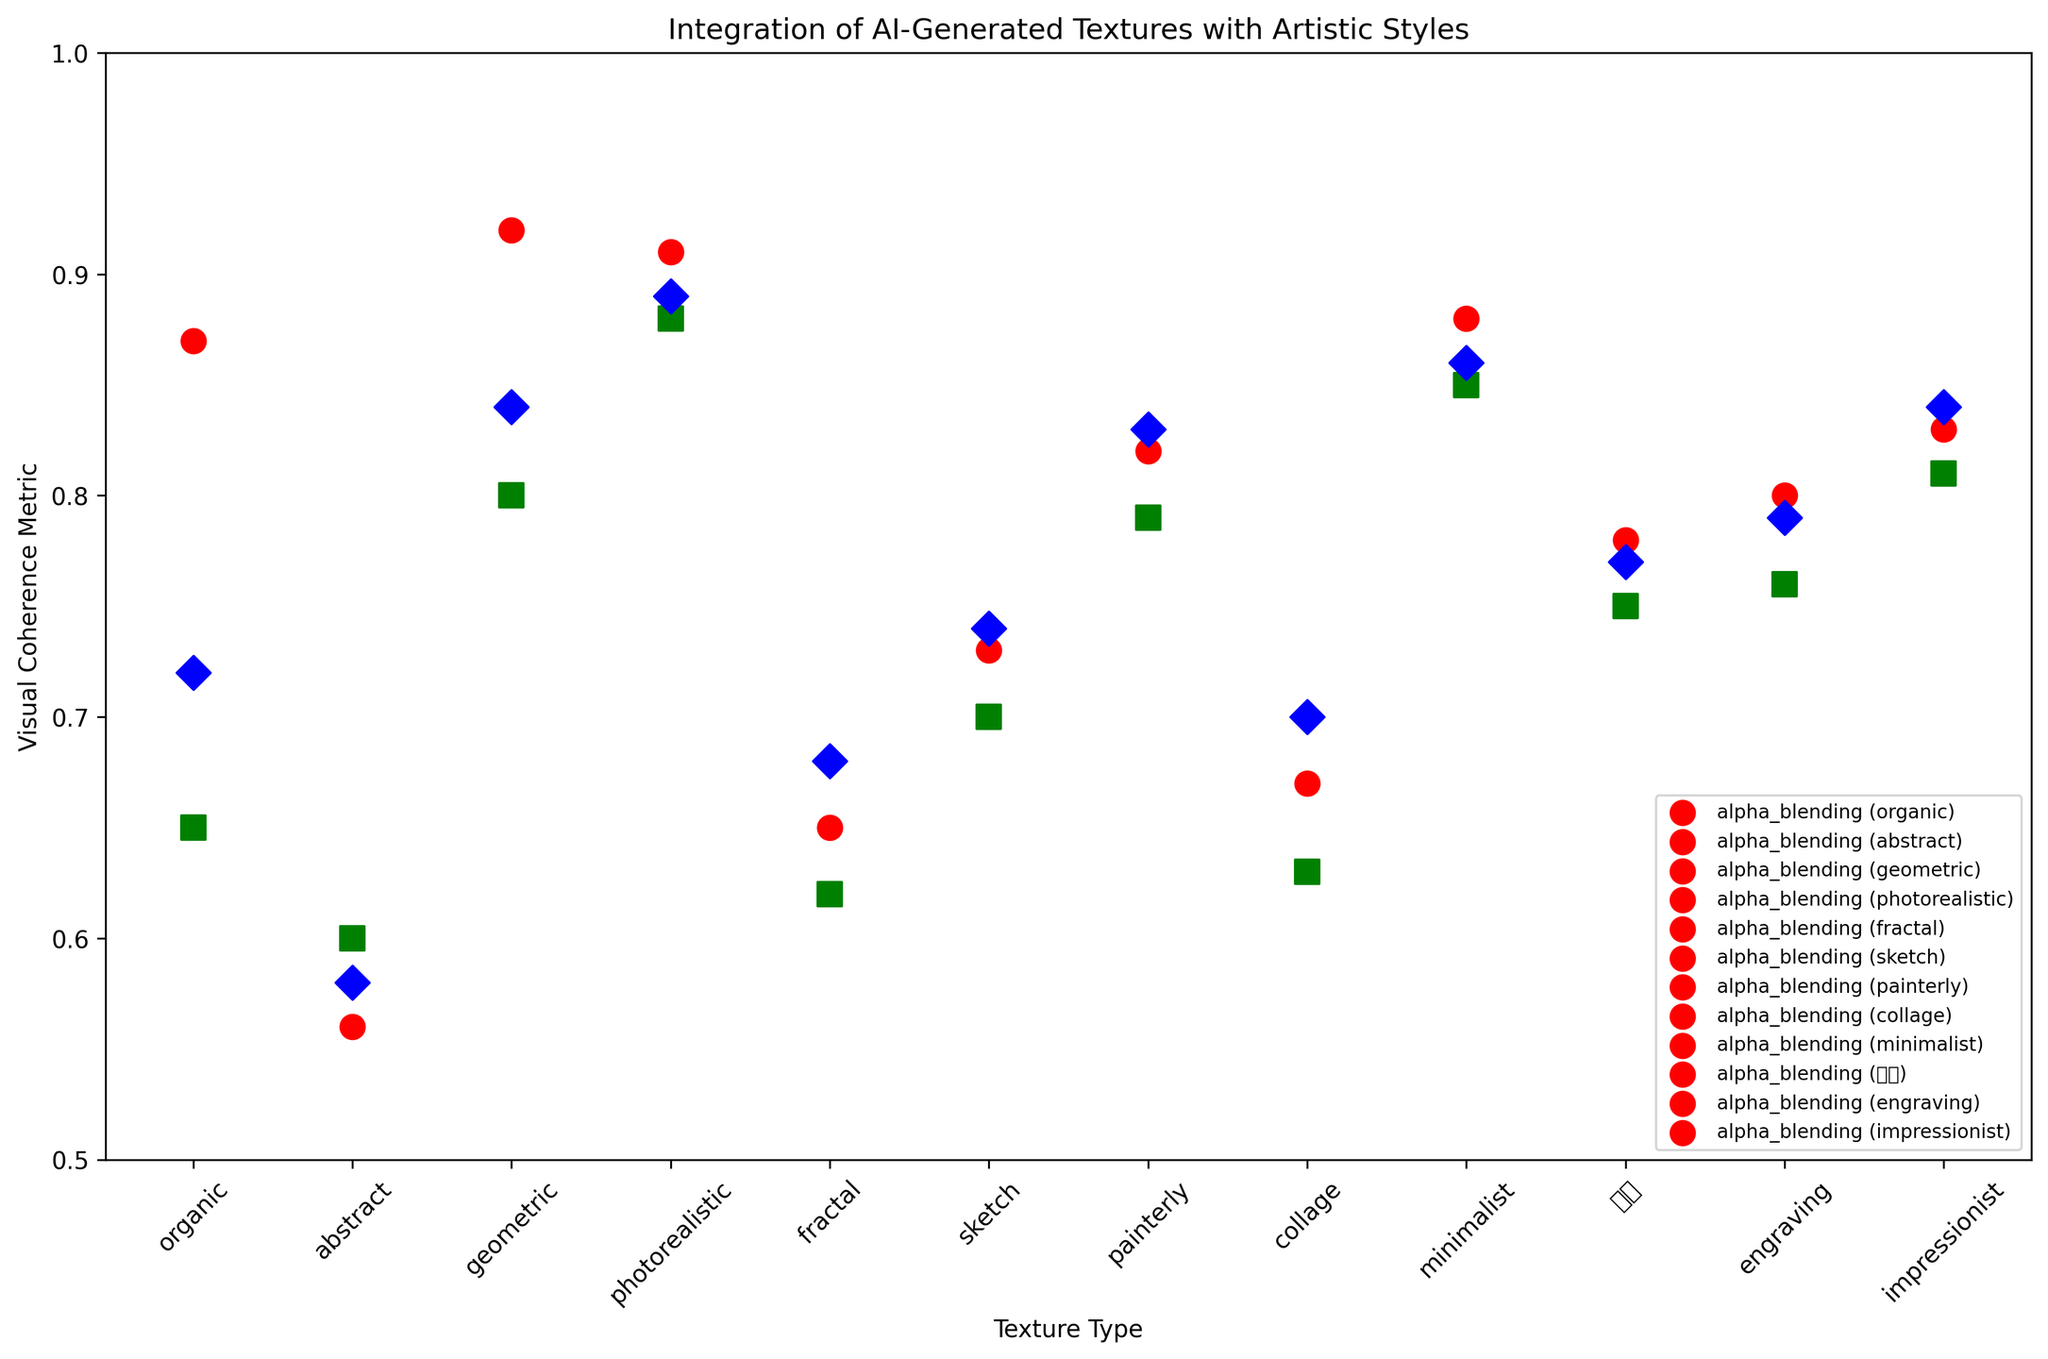Which blending technique has the highest visual coherence for geometric textures? Look at the visual coherence metric (Y-axis) for geometric textures when different blending techniques are used. The highest point is with alpha blending near 0.92.
Answer: Alpha blending How does the visual coherence metric for organic textures with alpha blending compare to that of fractal textures with additive blending? Compare the heights of the points for organic textures with alpha blending and fractal textures with additive blending. Organic textures with alpha blending reach 0.87, while fractal textures with additive blending reach 0.68.
Answer: Organic textures with alpha blending Which texture type displays the highest visual coherence metric across all blending techniques? Check the highest points on the Y-axis across all texture types and blending techniques. The highest value is for geometric textures with alpha blending at 0.92.
Answer: Geometric What is the median visual coherence metric of the blending techniques for minimalistic textures? There are three blending techniques for minimalistic textures: 0.88 (alpha blending), 0.85 (multiplicative blending), and 0.86 (additive blending). The median is the middle value when sorted: 0.86.
Answer: 0.86 Which blending technique generally results in lower visual coherence for abstract textures? Look at the visual coherence metrics for abstract textures with different blending techniques. The lowest point is for alpha blending at 0.56.
Answer: Alpha blending What is the range of visual coherence metrics for painterly textures across all blending techniques? Find the highest and lowest visual coherence metrics for painterly textures. The highest is 0.83 with additive blending, and the lowest is 0.79 with multiplicative blending. The range is 0.83 - 0.79.
Answer: 0.04 How does the visual coherence metric of additive blending for impressionist textures compare to that of alpha blending for sketch textures? Compare the heights of the points for these texture types. Impressionist textures with additive blending are at 0.84, while sketch textures with alpha blending are at 0.73.
Answer: Impressionist textures with additive blending Which texture type has the smallest visual coherence difference between alpha and multiplicative blending? Calculate the differences between alpha and multiplicative blending for each texture type and find the smallest difference. For sketch textures, it is 0.73 (alpha) - 0.70 (multiplicative) = 0.03.
Answer: Sketch Which texture type and blending technique combination yields the lowest visual coherence metric in the dataset? Identify the lowest point on the Y-axis across all texture types and blending techniques. It occurs for abstract textures with alpha blending at 0.56.
Answer: Abstract textures with alpha blending Is the visual coherence of organic textures higher for multiplicative blending or additive blending? Compare the heights of the points for organic textures with multiplicative and additive blending. Multiplicative blending is at 0.65, while additive blending is at 0.72.
Answer: Additive blending 